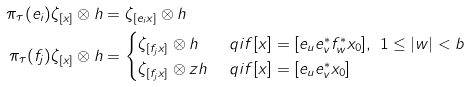<formula> <loc_0><loc_0><loc_500><loc_500>\pi _ { \tau } ( e _ { i } ) \zeta _ { [ x ] } \otimes h & = \zeta _ { [ e _ { i } x ] } \otimes h \\ \pi _ { \tau } ( f _ { j } ) \zeta _ { [ x ] } \otimes h & = \begin{cases} \zeta _ { [ f _ { j } x ] } \otimes h & \ q i f [ x ] = [ e _ { u } e _ { v } ^ { * } f _ { w } ^ { * } x _ { 0 } ] , \ 1 \leq | w | < b \\ \zeta _ { [ f _ { j } x ] } \otimes z h & \ q i f [ x ] = [ e _ { u } e _ { v } ^ { * } x _ { 0 } ] \end{cases}</formula> 